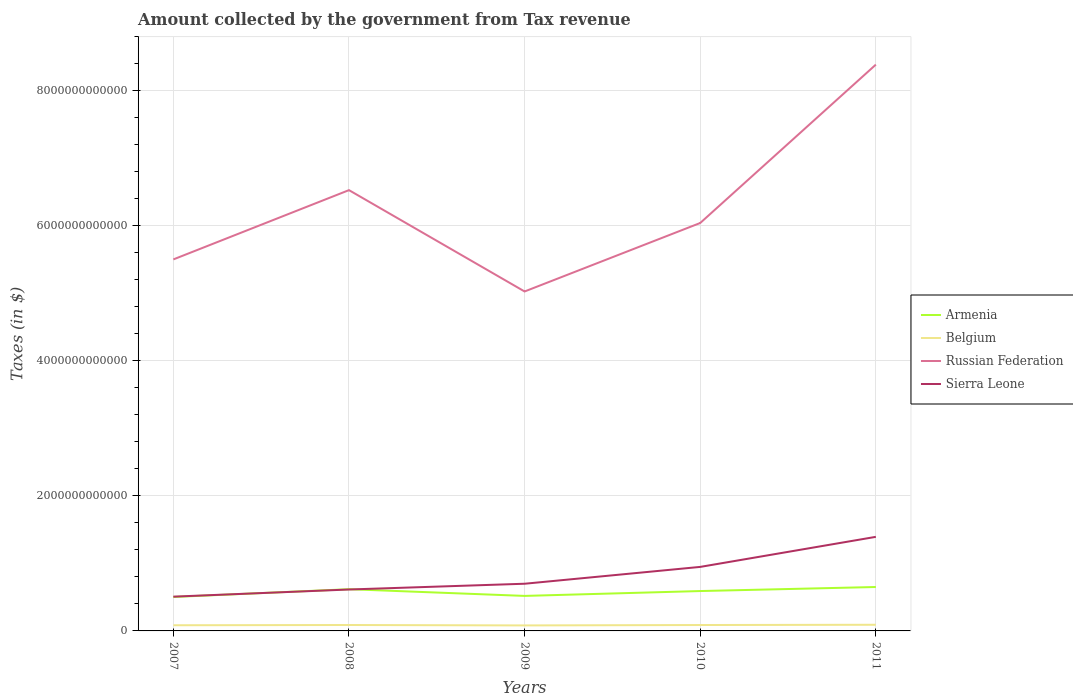How many different coloured lines are there?
Provide a short and direct response. 4. Is the number of lines equal to the number of legend labels?
Ensure brevity in your answer.  Yes. Across all years, what is the maximum amount collected by the government from tax revenue in Sierra Leone?
Ensure brevity in your answer.  5.07e+11. What is the total amount collected by the government from tax revenue in Sierra Leone in the graph?
Give a very brief answer. -4.45e+11. What is the difference between the highest and the second highest amount collected by the government from tax revenue in Russian Federation?
Make the answer very short. 3.36e+12. What is the difference between the highest and the lowest amount collected by the government from tax revenue in Sierra Leone?
Your response must be concise. 2. What is the difference between two consecutive major ticks on the Y-axis?
Give a very brief answer. 2.00e+12. Are the values on the major ticks of Y-axis written in scientific E-notation?
Your answer should be very brief. No. Does the graph contain any zero values?
Provide a short and direct response. No. Does the graph contain grids?
Your answer should be very brief. Yes. Where does the legend appear in the graph?
Provide a short and direct response. Center right. How are the legend labels stacked?
Your response must be concise. Vertical. What is the title of the graph?
Your answer should be very brief. Amount collected by the government from Tax revenue. What is the label or title of the X-axis?
Your answer should be compact. Years. What is the label or title of the Y-axis?
Provide a succinct answer. Taxes (in $). What is the Taxes (in $) in Armenia in 2007?
Offer a very short reply. 5.03e+11. What is the Taxes (in $) in Belgium in 2007?
Offer a very short reply. 8.41e+1. What is the Taxes (in $) in Russian Federation in 2007?
Provide a short and direct response. 5.50e+12. What is the Taxes (in $) of Sierra Leone in 2007?
Offer a terse response. 5.07e+11. What is the Taxes (in $) in Armenia in 2008?
Provide a short and direct response. 6.18e+11. What is the Taxes (in $) of Belgium in 2008?
Provide a short and direct response. 8.78e+1. What is the Taxes (in $) of Russian Federation in 2008?
Offer a very short reply. 6.53e+12. What is the Taxes (in $) of Sierra Leone in 2008?
Provide a succinct answer. 6.13e+11. What is the Taxes (in $) in Armenia in 2009?
Your answer should be very brief. 5.19e+11. What is the Taxes (in $) of Belgium in 2009?
Your response must be concise. 8.16e+1. What is the Taxes (in $) in Russian Federation in 2009?
Ensure brevity in your answer.  5.03e+12. What is the Taxes (in $) of Sierra Leone in 2009?
Your answer should be compact. 6.99e+11. What is the Taxes (in $) in Armenia in 2010?
Provide a short and direct response. 5.91e+11. What is the Taxes (in $) of Belgium in 2010?
Give a very brief answer. 8.74e+1. What is the Taxes (in $) of Russian Federation in 2010?
Provide a succinct answer. 6.04e+12. What is the Taxes (in $) in Sierra Leone in 2010?
Provide a short and direct response. 9.48e+11. What is the Taxes (in $) in Armenia in 2011?
Make the answer very short. 6.51e+11. What is the Taxes (in $) of Belgium in 2011?
Provide a short and direct response. 9.12e+1. What is the Taxes (in $) of Russian Federation in 2011?
Provide a short and direct response. 8.39e+12. What is the Taxes (in $) of Sierra Leone in 2011?
Make the answer very short. 1.39e+12. Across all years, what is the maximum Taxes (in $) in Armenia?
Give a very brief answer. 6.51e+11. Across all years, what is the maximum Taxes (in $) of Belgium?
Keep it short and to the point. 9.12e+1. Across all years, what is the maximum Taxes (in $) of Russian Federation?
Your response must be concise. 8.39e+12. Across all years, what is the maximum Taxes (in $) in Sierra Leone?
Give a very brief answer. 1.39e+12. Across all years, what is the minimum Taxes (in $) in Armenia?
Keep it short and to the point. 5.03e+11. Across all years, what is the minimum Taxes (in $) in Belgium?
Offer a very short reply. 8.16e+1. Across all years, what is the minimum Taxes (in $) in Russian Federation?
Ensure brevity in your answer.  5.03e+12. Across all years, what is the minimum Taxes (in $) in Sierra Leone?
Provide a short and direct response. 5.07e+11. What is the total Taxes (in $) in Armenia in the graph?
Your answer should be very brief. 2.88e+12. What is the total Taxes (in $) in Belgium in the graph?
Offer a very short reply. 4.32e+11. What is the total Taxes (in $) in Russian Federation in the graph?
Your answer should be compact. 3.15e+13. What is the total Taxes (in $) of Sierra Leone in the graph?
Your response must be concise. 4.16e+12. What is the difference between the Taxes (in $) of Armenia in 2007 and that in 2008?
Make the answer very short. -1.15e+11. What is the difference between the Taxes (in $) in Belgium in 2007 and that in 2008?
Your answer should be very brief. -3.72e+09. What is the difference between the Taxes (in $) of Russian Federation in 2007 and that in 2008?
Provide a succinct answer. -1.03e+12. What is the difference between the Taxes (in $) of Sierra Leone in 2007 and that in 2008?
Ensure brevity in your answer.  -1.06e+11. What is the difference between the Taxes (in $) of Armenia in 2007 and that in 2009?
Offer a very short reply. -1.59e+1. What is the difference between the Taxes (in $) of Belgium in 2007 and that in 2009?
Make the answer very short. 2.52e+09. What is the difference between the Taxes (in $) in Russian Federation in 2007 and that in 2009?
Keep it short and to the point. 4.75e+11. What is the difference between the Taxes (in $) in Sierra Leone in 2007 and that in 2009?
Make the answer very short. -1.91e+11. What is the difference between the Taxes (in $) in Armenia in 2007 and that in 2010?
Provide a succinct answer. -8.80e+1. What is the difference between the Taxes (in $) in Belgium in 2007 and that in 2010?
Keep it short and to the point. -3.30e+09. What is the difference between the Taxes (in $) in Russian Federation in 2007 and that in 2010?
Your answer should be very brief. -5.40e+11. What is the difference between the Taxes (in $) of Sierra Leone in 2007 and that in 2010?
Your response must be concise. -4.41e+11. What is the difference between the Taxes (in $) in Armenia in 2007 and that in 2011?
Ensure brevity in your answer.  -1.48e+11. What is the difference between the Taxes (in $) in Belgium in 2007 and that in 2011?
Provide a succinct answer. -7.14e+09. What is the difference between the Taxes (in $) of Russian Federation in 2007 and that in 2011?
Your answer should be very brief. -2.89e+12. What is the difference between the Taxes (in $) of Sierra Leone in 2007 and that in 2011?
Offer a terse response. -8.86e+11. What is the difference between the Taxes (in $) in Armenia in 2008 and that in 2009?
Ensure brevity in your answer.  9.95e+1. What is the difference between the Taxes (in $) of Belgium in 2008 and that in 2009?
Your answer should be compact. 6.24e+09. What is the difference between the Taxes (in $) in Russian Federation in 2008 and that in 2009?
Make the answer very short. 1.50e+12. What is the difference between the Taxes (in $) in Sierra Leone in 2008 and that in 2009?
Ensure brevity in your answer.  -8.54e+1. What is the difference between the Taxes (in $) in Armenia in 2008 and that in 2010?
Offer a very short reply. 2.74e+1. What is the difference between the Taxes (in $) in Belgium in 2008 and that in 2010?
Your answer should be compact. 4.16e+08. What is the difference between the Taxes (in $) of Russian Federation in 2008 and that in 2010?
Make the answer very short. 4.87e+11. What is the difference between the Taxes (in $) of Sierra Leone in 2008 and that in 2010?
Provide a succinct answer. -3.35e+11. What is the difference between the Taxes (in $) in Armenia in 2008 and that in 2011?
Give a very brief answer. -3.25e+1. What is the difference between the Taxes (in $) in Belgium in 2008 and that in 2011?
Offer a terse response. -3.42e+09. What is the difference between the Taxes (in $) in Russian Federation in 2008 and that in 2011?
Ensure brevity in your answer.  -1.86e+12. What is the difference between the Taxes (in $) of Sierra Leone in 2008 and that in 2011?
Offer a terse response. -7.80e+11. What is the difference between the Taxes (in $) in Armenia in 2009 and that in 2010?
Provide a short and direct response. -7.21e+1. What is the difference between the Taxes (in $) in Belgium in 2009 and that in 2010?
Your answer should be compact. -5.83e+09. What is the difference between the Taxes (in $) in Russian Federation in 2009 and that in 2010?
Ensure brevity in your answer.  -1.01e+12. What is the difference between the Taxes (in $) of Sierra Leone in 2009 and that in 2010?
Offer a terse response. -2.49e+11. What is the difference between the Taxes (in $) in Armenia in 2009 and that in 2011?
Give a very brief answer. -1.32e+11. What is the difference between the Taxes (in $) of Belgium in 2009 and that in 2011?
Your response must be concise. -9.66e+09. What is the difference between the Taxes (in $) in Russian Federation in 2009 and that in 2011?
Keep it short and to the point. -3.36e+12. What is the difference between the Taxes (in $) in Sierra Leone in 2009 and that in 2011?
Your answer should be compact. -6.95e+11. What is the difference between the Taxes (in $) in Armenia in 2010 and that in 2011?
Offer a very short reply. -5.99e+1. What is the difference between the Taxes (in $) of Belgium in 2010 and that in 2011?
Provide a short and direct response. -3.83e+09. What is the difference between the Taxes (in $) in Russian Federation in 2010 and that in 2011?
Offer a terse response. -2.35e+12. What is the difference between the Taxes (in $) in Sierra Leone in 2010 and that in 2011?
Keep it short and to the point. -4.45e+11. What is the difference between the Taxes (in $) of Armenia in 2007 and the Taxes (in $) of Belgium in 2008?
Your answer should be very brief. 4.15e+11. What is the difference between the Taxes (in $) in Armenia in 2007 and the Taxes (in $) in Russian Federation in 2008?
Your answer should be compact. -6.03e+12. What is the difference between the Taxes (in $) of Armenia in 2007 and the Taxes (in $) of Sierra Leone in 2008?
Your answer should be compact. -1.11e+11. What is the difference between the Taxes (in $) of Belgium in 2007 and the Taxes (in $) of Russian Federation in 2008?
Your response must be concise. -6.45e+12. What is the difference between the Taxes (in $) in Belgium in 2007 and the Taxes (in $) in Sierra Leone in 2008?
Offer a terse response. -5.29e+11. What is the difference between the Taxes (in $) of Russian Federation in 2007 and the Taxes (in $) of Sierra Leone in 2008?
Ensure brevity in your answer.  4.89e+12. What is the difference between the Taxes (in $) of Armenia in 2007 and the Taxes (in $) of Belgium in 2009?
Give a very brief answer. 4.21e+11. What is the difference between the Taxes (in $) of Armenia in 2007 and the Taxes (in $) of Russian Federation in 2009?
Offer a very short reply. -4.53e+12. What is the difference between the Taxes (in $) in Armenia in 2007 and the Taxes (in $) in Sierra Leone in 2009?
Provide a succinct answer. -1.96e+11. What is the difference between the Taxes (in $) in Belgium in 2007 and the Taxes (in $) in Russian Federation in 2009?
Offer a very short reply. -4.94e+12. What is the difference between the Taxes (in $) of Belgium in 2007 and the Taxes (in $) of Sierra Leone in 2009?
Give a very brief answer. -6.15e+11. What is the difference between the Taxes (in $) in Russian Federation in 2007 and the Taxes (in $) in Sierra Leone in 2009?
Your answer should be very brief. 4.80e+12. What is the difference between the Taxes (in $) in Armenia in 2007 and the Taxes (in $) in Belgium in 2010?
Offer a very short reply. 4.15e+11. What is the difference between the Taxes (in $) of Armenia in 2007 and the Taxes (in $) of Russian Federation in 2010?
Your answer should be very brief. -5.54e+12. What is the difference between the Taxes (in $) of Armenia in 2007 and the Taxes (in $) of Sierra Leone in 2010?
Give a very brief answer. -4.46e+11. What is the difference between the Taxes (in $) in Belgium in 2007 and the Taxes (in $) in Russian Federation in 2010?
Provide a short and direct response. -5.96e+12. What is the difference between the Taxes (in $) of Belgium in 2007 and the Taxes (in $) of Sierra Leone in 2010?
Give a very brief answer. -8.64e+11. What is the difference between the Taxes (in $) of Russian Federation in 2007 and the Taxes (in $) of Sierra Leone in 2010?
Ensure brevity in your answer.  4.55e+12. What is the difference between the Taxes (in $) in Armenia in 2007 and the Taxes (in $) in Belgium in 2011?
Provide a succinct answer. 4.11e+11. What is the difference between the Taxes (in $) of Armenia in 2007 and the Taxes (in $) of Russian Federation in 2011?
Your answer should be compact. -7.89e+12. What is the difference between the Taxes (in $) of Armenia in 2007 and the Taxes (in $) of Sierra Leone in 2011?
Give a very brief answer. -8.91e+11. What is the difference between the Taxes (in $) in Belgium in 2007 and the Taxes (in $) in Russian Federation in 2011?
Make the answer very short. -8.30e+12. What is the difference between the Taxes (in $) of Belgium in 2007 and the Taxes (in $) of Sierra Leone in 2011?
Keep it short and to the point. -1.31e+12. What is the difference between the Taxes (in $) in Russian Federation in 2007 and the Taxes (in $) in Sierra Leone in 2011?
Offer a very short reply. 4.11e+12. What is the difference between the Taxes (in $) in Armenia in 2008 and the Taxes (in $) in Belgium in 2009?
Your answer should be very brief. 5.37e+11. What is the difference between the Taxes (in $) in Armenia in 2008 and the Taxes (in $) in Russian Federation in 2009?
Ensure brevity in your answer.  -4.41e+12. What is the difference between the Taxes (in $) of Armenia in 2008 and the Taxes (in $) of Sierra Leone in 2009?
Your response must be concise. -8.08e+1. What is the difference between the Taxes (in $) of Belgium in 2008 and the Taxes (in $) of Russian Federation in 2009?
Offer a very short reply. -4.94e+12. What is the difference between the Taxes (in $) of Belgium in 2008 and the Taxes (in $) of Sierra Leone in 2009?
Your response must be concise. -6.11e+11. What is the difference between the Taxes (in $) of Russian Federation in 2008 and the Taxes (in $) of Sierra Leone in 2009?
Your answer should be compact. 5.83e+12. What is the difference between the Taxes (in $) in Armenia in 2008 and the Taxes (in $) in Belgium in 2010?
Keep it short and to the point. 5.31e+11. What is the difference between the Taxes (in $) in Armenia in 2008 and the Taxes (in $) in Russian Federation in 2010?
Give a very brief answer. -5.42e+12. What is the difference between the Taxes (in $) in Armenia in 2008 and the Taxes (in $) in Sierra Leone in 2010?
Provide a succinct answer. -3.30e+11. What is the difference between the Taxes (in $) in Belgium in 2008 and the Taxes (in $) in Russian Federation in 2010?
Your answer should be very brief. -5.95e+12. What is the difference between the Taxes (in $) in Belgium in 2008 and the Taxes (in $) in Sierra Leone in 2010?
Offer a terse response. -8.61e+11. What is the difference between the Taxes (in $) of Russian Federation in 2008 and the Taxes (in $) of Sierra Leone in 2010?
Ensure brevity in your answer.  5.58e+12. What is the difference between the Taxes (in $) of Armenia in 2008 and the Taxes (in $) of Belgium in 2011?
Your answer should be compact. 5.27e+11. What is the difference between the Taxes (in $) in Armenia in 2008 and the Taxes (in $) in Russian Federation in 2011?
Your answer should be very brief. -7.77e+12. What is the difference between the Taxes (in $) of Armenia in 2008 and the Taxes (in $) of Sierra Leone in 2011?
Give a very brief answer. -7.76e+11. What is the difference between the Taxes (in $) of Belgium in 2008 and the Taxes (in $) of Russian Federation in 2011?
Your answer should be compact. -8.30e+12. What is the difference between the Taxes (in $) of Belgium in 2008 and the Taxes (in $) of Sierra Leone in 2011?
Your response must be concise. -1.31e+12. What is the difference between the Taxes (in $) of Russian Federation in 2008 and the Taxes (in $) of Sierra Leone in 2011?
Your answer should be compact. 5.14e+12. What is the difference between the Taxes (in $) of Armenia in 2009 and the Taxes (in $) of Belgium in 2010?
Your answer should be compact. 4.31e+11. What is the difference between the Taxes (in $) of Armenia in 2009 and the Taxes (in $) of Russian Federation in 2010?
Offer a very short reply. -5.52e+12. What is the difference between the Taxes (in $) in Armenia in 2009 and the Taxes (in $) in Sierra Leone in 2010?
Ensure brevity in your answer.  -4.30e+11. What is the difference between the Taxes (in $) of Belgium in 2009 and the Taxes (in $) of Russian Federation in 2010?
Provide a succinct answer. -5.96e+12. What is the difference between the Taxes (in $) of Belgium in 2009 and the Taxes (in $) of Sierra Leone in 2010?
Offer a very short reply. -8.67e+11. What is the difference between the Taxes (in $) in Russian Federation in 2009 and the Taxes (in $) in Sierra Leone in 2010?
Offer a very short reply. 4.08e+12. What is the difference between the Taxes (in $) of Armenia in 2009 and the Taxes (in $) of Belgium in 2011?
Your answer should be very brief. 4.27e+11. What is the difference between the Taxes (in $) of Armenia in 2009 and the Taxes (in $) of Russian Federation in 2011?
Provide a short and direct response. -7.87e+12. What is the difference between the Taxes (in $) in Armenia in 2009 and the Taxes (in $) in Sierra Leone in 2011?
Keep it short and to the point. -8.75e+11. What is the difference between the Taxes (in $) in Belgium in 2009 and the Taxes (in $) in Russian Federation in 2011?
Provide a succinct answer. -8.31e+12. What is the difference between the Taxes (in $) of Belgium in 2009 and the Taxes (in $) of Sierra Leone in 2011?
Provide a short and direct response. -1.31e+12. What is the difference between the Taxes (in $) of Russian Federation in 2009 and the Taxes (in $) of Sierra Leone in 2011?
Your response must be concise. 3.63e+12. What is the difference between the Taxes (in $) of Armenia in 2010 and the Taxes (in $) of Belgium in 2011?
Provide a succinct answer. 4.99e+11. What is the difference between the Taxes (in $) of Armenia in 2010 and the Taxes (in $) of Russian Federation in 2011?
Ensure brevity in your answer.  -7.80e+12. What is the difference between the Taxes (in $) of Armenia in 2010 and the Taxes (in $) of Sierra Leone in 2011?
Give a very brief answer. -8.03e+11. What is the difference between the Taxes (in $) of Belgium in 2010 and the Taxes (in $) of Russian Federation in 2011?
Give a very brief answer. -8.30e+12. What is the difference between the Taxes (in $) of Belgium in 2010 and the Taxes (in $) of Sierra Leone in 2011?
Provide a short and direct response. -1.31e+12. What is the difference between the Taxes (in $) in Russian Federation in 2010 and the Taxes (in $) in Sierra Leone in 2011?
Your answer should be compact. 4.65e+12. What is the average Taxes (in $) of Armenia per year?
Provide a succinct answer. 5.76e+11. What is the average Taxes (in $) in Belgium per year?
Your response must be concise. 8.64e+1. What is the average Taxes (in $) of Russian Federation per year?
Give a very brief answer. 6.30e+12. What is the average Taxes (in $) of Sierra Leone per year?
Offer a terse response. 8.32e+11. In the year 2007, what is the difference between the Taxes (in $) of Armenia and Taxes (in $) of Belgium?
Make the answer very short. 4.19e+11. In the year 2007, what is the difference between the Taxes (in $) of Armenia and Taxes (in $) of Russian Federation?
Provide a short and direct response. -5.00e+12. In the year 2007, what is the difference between the Taxes (in $) of Armenia and Taxes (in $) of Sierra Leone?
Provide a succinct answer. -4.76e+09. In the year 2007, what is the difference between the Taxes (in $) of Belgium and Taxes (in $) of Russian Federation?
Give a very brief answer. -5.42e+12. In the year 2007, what is the difference between the Taxes (in $) of Belgium and Taxes (in $) of Sierra Leone?
Offer a terse response. -4.23e+11. In the year 2007, what is the difference between the Taxes (in $) of Russian Federation and Taxes (in $) of Sierra Leone?
Your answer should be compact. 5.00e+12. In the year 2008, what is the difference between the Taxes (in $) of Armenia and Taxes (in $) of Belgium?
Provide a succinct answer. 5.30e+11. In the year 2008, what is the difference between the Taxes (in $) of Armenia and Taxes (in $) of Russian Federation?
Offer a terse response. -5.91e+12. In the year 2008, what is the difference between the Taxes (in $) in Armenia and Taxes (in $) in Sierra Leone?
Keep it short and to the point. 4.60e+09. In the year 2008, what is the difference between the Taxes (in $) in Belgium and Taxes (in $) in Russian Federation?
Give a very brief answer. -6.44e+12. In the year 2008, what is the difference between the Taxes (in $) of Belgium and Taxes (in $) of Sierra Leone?
Offer a very short reply. -5.26e+11. In the year 2008, what is the difference between the Taxes (in $) in Russian Federation and Taxes (in $) in Sierra Leone?
Provide a succinct answer. 5.92e+12. In the year 2009, what is the difference between the Taxes (in $) of Armenia and Taxes (in $) of Belgium?
Provide a succinct answer. 4.37e+11. In the year 2009, what is the difference between the Taxes (in $) of Armenia and Taxes (in $) of Russian Federation?
Provide a short and direct response. -4.51e+12. In the year 2009, what is the difference between the Taxes (in $) in Armenia and Taxes (in $) in Sierra Leone?
Provide a short and direct response. -1.80e+11. In the year 2009, what is the difference between the Taxes (in $) of Belgium and Taxes (in $) of Russian Federation?
Keep it short and to the point. -4.95e+12. In the year 2009, what is the difference between the Taxes (in $) of Belgium and Taxes (in $) of Sierra Leone?
Your response must be concise. -6.17e+11. In the year 2009, what is the difference between the Taxes (in $) in Russian Federation and Taxes (in $) in Sierra Leone?
Make the answer very short. 4.33e+12. In the year 2010, what is the difference between the Taxes (in $) of Armenia and Taxes (in $) of Belgium?
Offer a very short reply. 5.03e+11. In the year 2010, what is the difference between the Taxes (in $) in Armenia and Taxes (in $) in Russian Federation?
Give a very brief answer. -5.45e+12. In the year 2010, what is the difference between the Taxes (in $) of Armenia and Taxes (in $) of Sierra Leone?
Offer a very short reply. -3.58e+11. In the year 2010, what is the difference between the Taxes (in $) in Belgium and Taxes (in $) in Russian Federation?
Offer a terse response. -5.96e+12. In the year 2010, what is the difference between the Taxes (in $) in Belgium and Taxes (in $) in Sierra Leone?
Keep it short and to the point. -8.61e+11. In the year 2010, what is the difference between the Taxes (in $) in Russian Federation and Taxes (in $) in Sierra Leone?
Offer a terse response. 5.09e+12. In the year 2011, what is the difference between the Taxes (in $) of Armenia and Taxes (in $) of Belgium?
Ensure brevity in your answer.  5.59e+11. In the year 2011, what is the difference between the Taxes (in $) of Armenia and Taxes (in $) of Russian Federation?
Your response must be concise. -7.74e+12. In the year 2011, what is the difference between the Taxes (in $) in Armenia and Taxes (in $) in Sierra Leone?
Your answer should be compact. -7.43e+11. In the year 2011, what is the difference between the Taxes (in $) of Belgium and Taxes (in $) of Russian Federation?
Your answer should be compact. -8.30e+12. In the year 2011, what is the difference between the Taxes (in $) in Belgium and Taxes (in $) in Sierra Leone?
Offer a terse response. -1.30e+12. In the year 2011, what is the difference between the Taxes (in $) of Russian Federation and Taxes (in $) of Sierra Leone?
Your answer should be very brief. 6.99e+12. What is the ratio of the Taxes (in $) of Armenia in 2007 to that in 2008?
Provide a short and direct response. 0.81. What is the ratio of the Taxes (in $) in Belgium in 2007 to that in 2008?
Provide a succinct answer. 0.96. What is the ratio of the Taxes (in $) of Russian Federation in 2007 to that in 2008?
Offer a very short reply. 0.84. What is the ratio of the Taxes (in $) in Sierra Leone in 2007 to that in 2008?
Ensure brevity in your answer.  0.83. What is the ratio of the Taxes (in $) of Armenia in 2007 to that in 2009?
Offer a terse response. 0.97. What is the ratio of the Taxes (in $) of Belgium in 2007 to that in 2009?
Ensure brevity in your answer.  1.03. What is the ratio of the Taxes (in $) in Russian Federation in 2007 to that in 2009?
Your answer should be very brief. 1.09. What is the ratio of the Taxes (in $) of Sierra Leone in 2007 to that in 2009?
Make the answer very short. 0.73. What is the ratio of the Taxes (in $) of Armenia in 2007 to that in 2010?
Make the answer very short. 0.85. What is the ratio of the Taxes (in $) in Belgium in 2007 to that in 2010?
Your answer should be very brief. 0.96. What is the ratio of the Taxes (in $) of Russian Federation in 2007 to that in 2010?
Offer a very short reply. 0.91. What is the ratio of the Taxes (in $) of Sierra Leone in 2007 to that in 2010?
Offer a very short reply. 0.54. What is the ratio of the Taxes (in $) in Armenia in 2007 to that in 2011?
Provide a short and direct response. 0.77. What is the ratio of the Taxes (in $) of Belgium in 2007 to that in 2011?
Keep it short and to the point. 0.92. What is the ratio of the Taxes (in $) of Russian Federation in 2007 to that in 2011?
Ensure brevity in your answer.  0.66. What is the ratio of the Taxes (in $) of Sierra Leone in 2007 to that in 2011?
Provide a short and direct response. 0.36. What is the ratio of the Taxes (in $) in Armenia in 2008 to that in 2009?
Provide a short and direct response. 1.19. What is the ratio of the Taxes (in $) in Belgium in 2008 to that in 2009?
Give a very brief answer. 1.08. What is the ratio of the Taxes (in $) in Russian Federation in 2008 to that in 2009?
Make the answer very short. 1.3. What is the ratio of the Taxes (in $) in Sierra Leone in 2008 to that in 2009?
Make the answer very short. 0.88. What is the ratio of the Taxes (in $) in Armenia in 2008 to that in 2010?
Ensure brevity in your answer.  1.05. What is the ratio of the Taxes (in $) in Belgium in 2008 to that in 2010?
Keep it short and to the point. 1. What is the ratio of the Taxes (in $) of Russian Federation in 2008 to that in 2010?
Offer a very short reply. 1.08. What is the ratio of the Taxes (in $) of Sierra Leone in 2008 to that in 2010?
Your response must be concise. 0.65. What is the ratio of the Taxes (in $) of Armenia in 2008 to that in 2011?
Your answer should be very brief. 0.95. What is the ratio of the Taxes (in $) of Belgium in 2008 to that in 2011?
Offer a terse response. 0.96. What is the ratio of the Taxes (in $) of Russian Federation in 2008 to that in 2011?
Offer a very short reply. 0.78. What is the ratio of the Taxes (in $) of Sierra Leone in 2008 to that in 2011?
Offer a very short reply. 0.44. What is the ratio of the Taxes (in $) of Armenia in 2009 to that in 2010?
Make the answer very short. 0.88. What is the ratio of the Taxes (in $) in Russian Federation in 2009 to that in 2010?
Keep it short and to the point. 0.83. What is the ratio of the Taxes (in $) of Sierra Leone in 2009 to that in 2010?
Your answer should be compact. 0.74. What is the ratio of the Taxes (in $) of Armenia in 2009 to that in 2011?
Offer a terse response. 0.8. What is the ratio of the Taxes (in $) in Belgium in 2009 to that in 2011?
Make the answer very short. 0.89. What is the ratio of the Taxes (in $) in Russian Federation in 2009 to that in 2011?
Give a very brief answer. 0.6. What is the ratio of the Taxes (in $) in Sierra Leone in 2009 to that in 2011?
Your answer should be very brief. 0.5. What is the ratio of the Taxes (in $) in Armenia in 2010 to that in 2011?
Make the answer very short. 0.91. What is the ratio of the Taxes (in $) of Belgium in 2010 to that in 2011?
Give a very brief answer. 0.96. What is the ratio of the Taxes (in $) of Russian Federation in 2010 to that in 2011?
Your answer should be compact. 0.72. What is the ratio of the Taxes (in $) of Sierra Leone in 2010 to that in 2011?
Your answer should be very brief. 0.68. What is the difference between the highest and the second highest Taxes (in $) of Armenia?
Your response must be concise. 3.25e+1. What is the difference between the highest and the second highest Taxes (in $) in Belgium?
Give a very brief answer. 3.42e+09. What is the difference between the highest and the second highest Taxes (in $) of Russian Federation?
Ensure brevity in your answer.  1.86e+12. What is the difference between the highest and the second highest Taxes (in $) of Sierra Leone?
Provide a succinct answer. 4.45e+11. What is the difference between the highest and the lowest Taxes (in $) in Armenia?
Your response must be concise. 1.48e+11. What is the difference between the highest and the lowest Taxes (in $) of Belgium?
Give a very brief answer. 9.66e+09. What is the difference between the highest and the lowest Taxes (in $) of Russian Federation?
Ensure brevity in your answer.  3.36e+12. What is the difference between the highest and the lowest Taxes (in $) of Sierra Leone?
Offer a very short reply. 8.86e+11. 